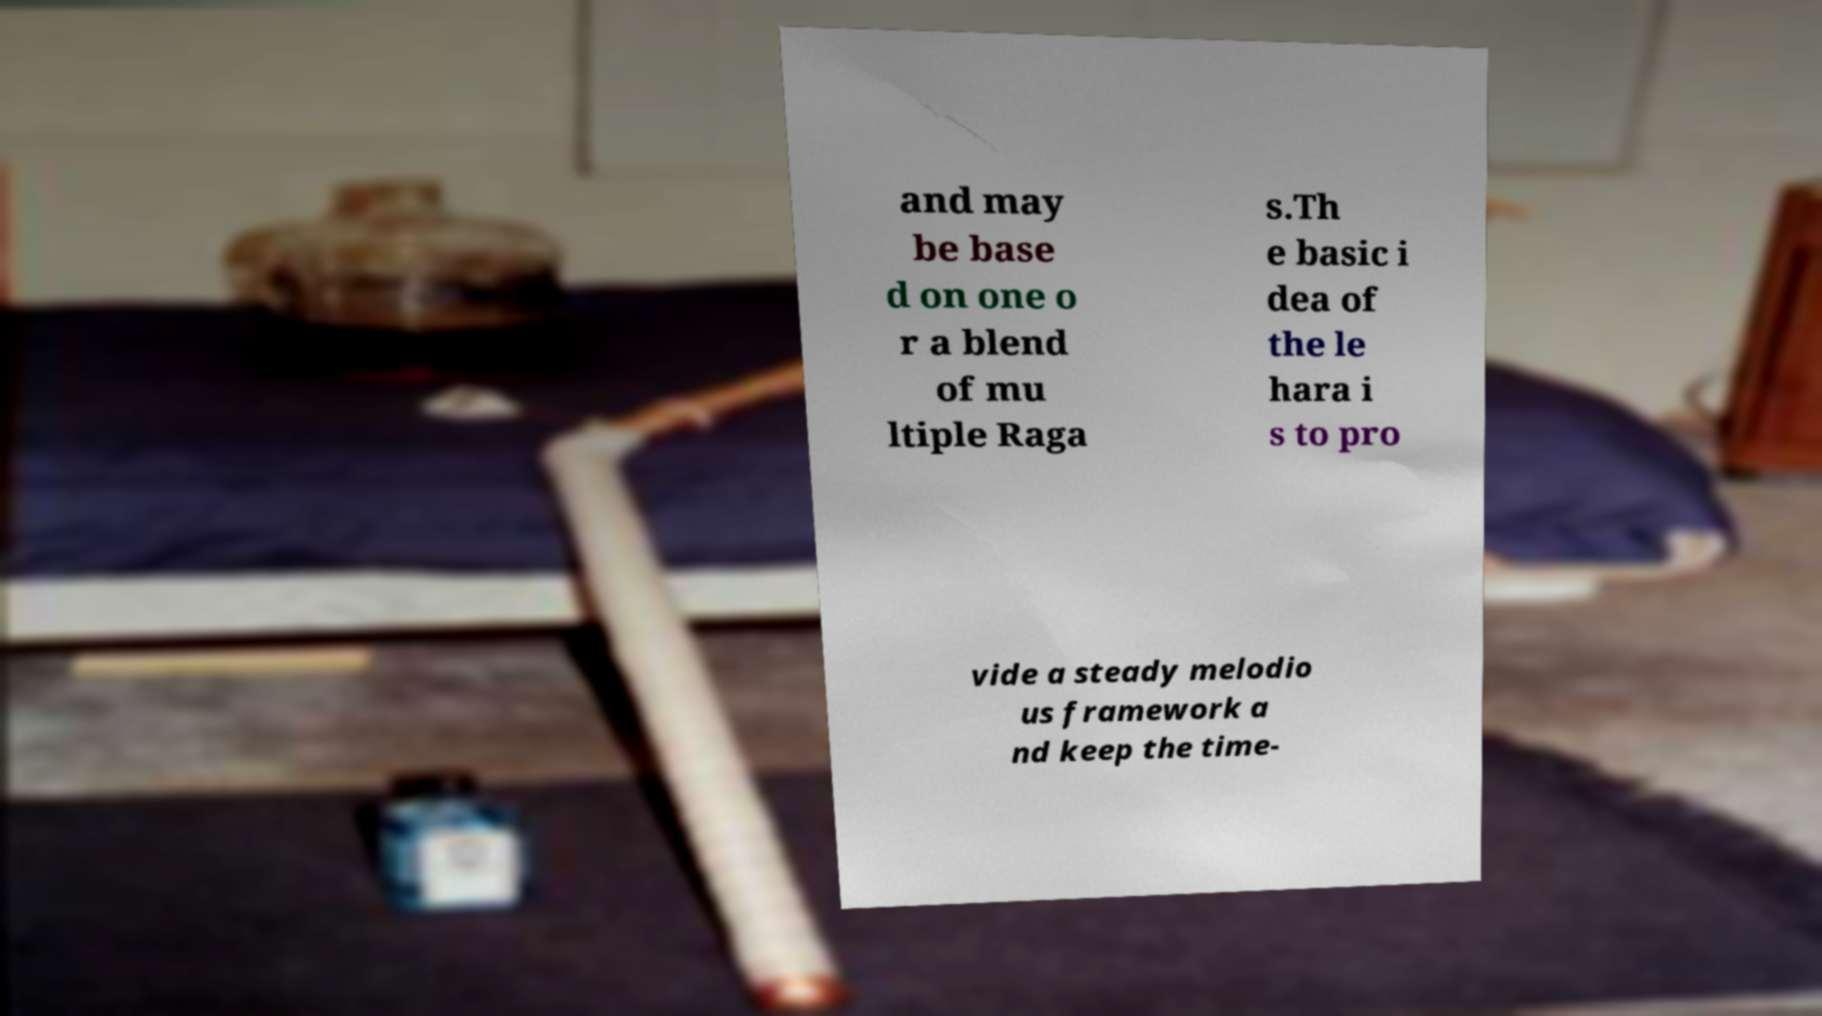Please identify and transcribe the text found in this image. and may be base d on one o r a blend of mu ltiple Raga s.Th e basic i dea of the le hara i s to pro vide a steady melodio us framework a nd keep the time- 